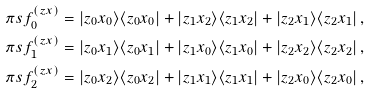<formula> <loc_0><loc_0><loc_500><loc_500>\pi s f _ { 0 } ^ { ( z x ) } & = | z _ { 0 } x _ { 0 } \rangle \langle { z } _ { 0 } x _ { 0 } | + | z _ { 1 } x _ { 2 } \rangle \langle { z } _ { 1 } x _ { 2 } | + | z _ { 2 } x _ { 1 } \rangle \langle { z } _ { 2 } x _ { 1 } | \, , \\ \pi s f _ { 1 } ^ { ( z x ) } & = | z _ { 0 } x _ { 1 } \rangle \langle { z } _ { 0 } x _ { 1 } | + | z _ { 1 } x _ { 0 } \rangle \langle { z } _ { 1 } x _ { 0 } | + | z _ { 2 } x _ { 2 } \rangle \langle { z } _ { 2 } x _ { 2 } | \, , \\ \pi s f _ { 2 } ^ { ( z x ) } & = | z _ { 0 } x _ { 2 } \rangle \langle { z } _ { 0 } x _ { 2 } | + | z _ { 1 } x _ { 1 } \rangle \langle { z } _ { 1 } x _ { 1 } | + | z _ { 2 } x _ { 0 } \rangle \langle { z } _ { 2 } x _ { 0 } | \, ,</formula> 